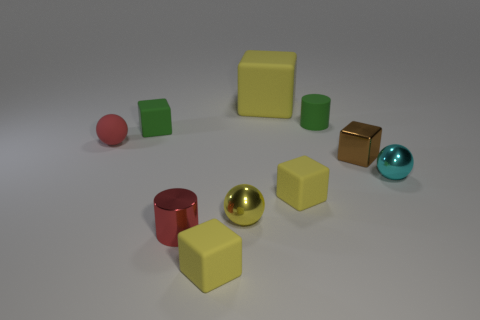What shape is the red rubber object that is the same size as the metal cube?
Keep it short and to the point. Sphere. There is a big object that is made of the same material as the small green cylinder; what color is it?
Your response must be concise. Yellow. Does the large yellow thing have the same shape as the small red object on the right side of the tiny red rubber object?
Offer a terse response. No. There is a tiny object that is the same color as the small shiny cylinder; what is it made of?
Make the answer very short. Rubber. What is the material of the green cylinder that is the same size as the red matte sphere?
Offer a very short reply. Rubber. Is there a tiny rubber object of the same color as the metallic cylinder?
Your response must be concise. Yes. What is the shape of the small thing that is both to the right of the tiny red cylinder and in front of the tiny yellow metal object?
Your answer should be very brief. Cube. How many red objects are made of the same material as the green cube?
Offer a terse response. 1. Are there fewer tiny matte things that are in front of the red ball than small matte objects to the left of the large yellow cube?
Ensure brevity in your answer.  Yes. The small red object on the right side of the green thing that is to the left of the tiny metallic ball that is left of the brown metal thing is made of what material?
Make the answer very short. Metal. 